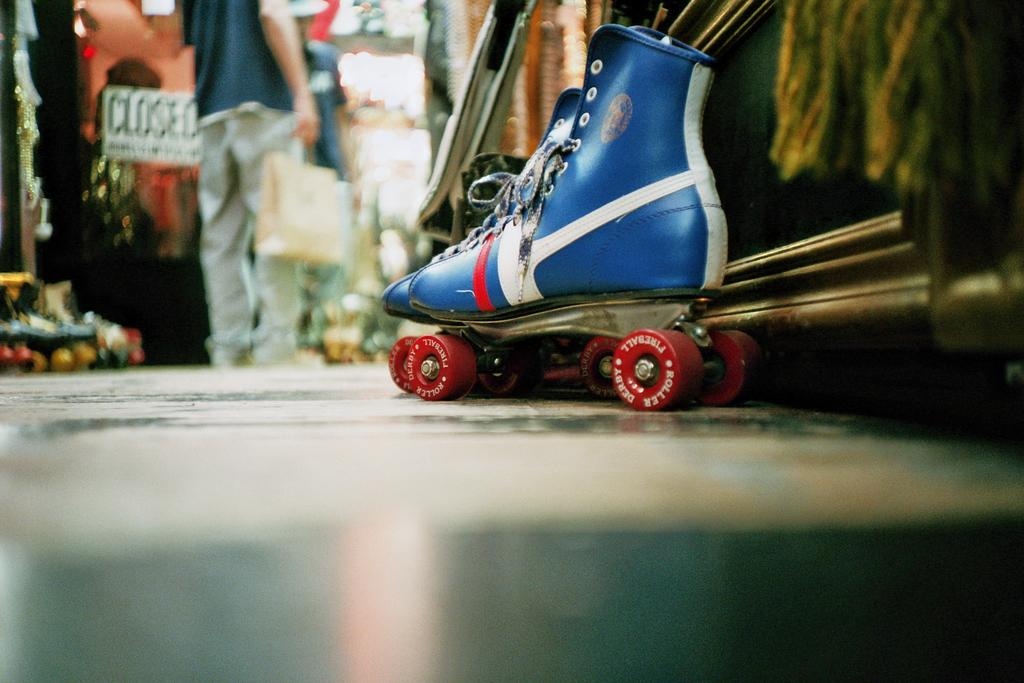What type of footwear is on the floor in the image? There are quad skates on the floor in the image. Can you describe the people in the background of the image? Unfortunately, the provided facts do not give any information about the people in the background. What might be the purpose of the quad skates in the image? The purpose of the quad skates is not explicitly stated in the facts, but they are likely used for skating or recreational activities. What type of ship can be seen sailing in the background of the image? There is no ship visible in the image; it only features quad skates on the floor and people in the background. Can you describe the letter that is being written on the cushion in the image? There is no letter or cushion present in the image. 